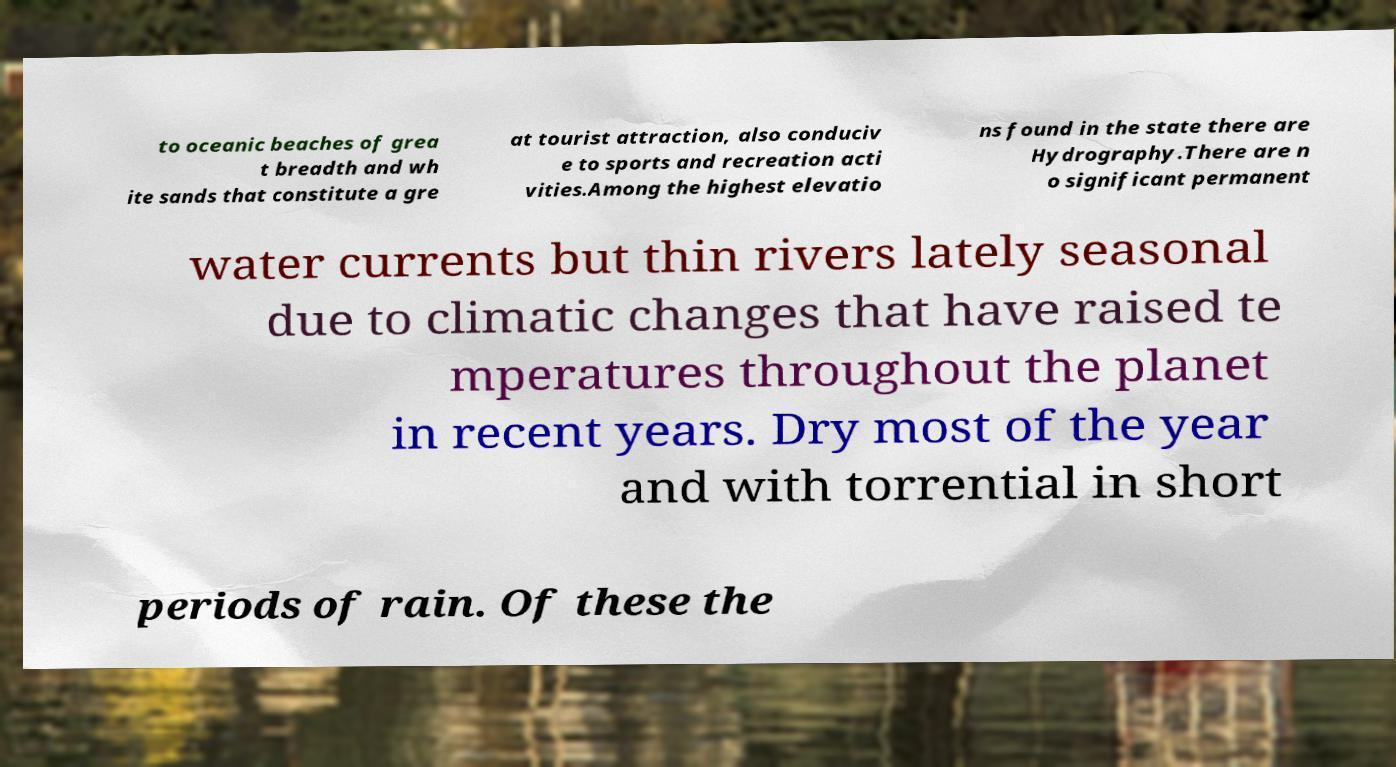Can you read and provide the text displayed in the image?This photo seems to have some interesting text. Can you extract and type it out for me? to oceanic beaches of grea t breadth and wh ite sands that constitute a gre at tourist attraction, also conduciv e to sports and recreation acti vities.Among the highest elevatio ns found in the state there are Hydrography.There are n o significant permanent water currents but thin rivers lately seasonal due to climatic changes that have raised te mperatures throughout the planet in recent years. Dry most of the year and with torrential in short periods of rain. Of these the 